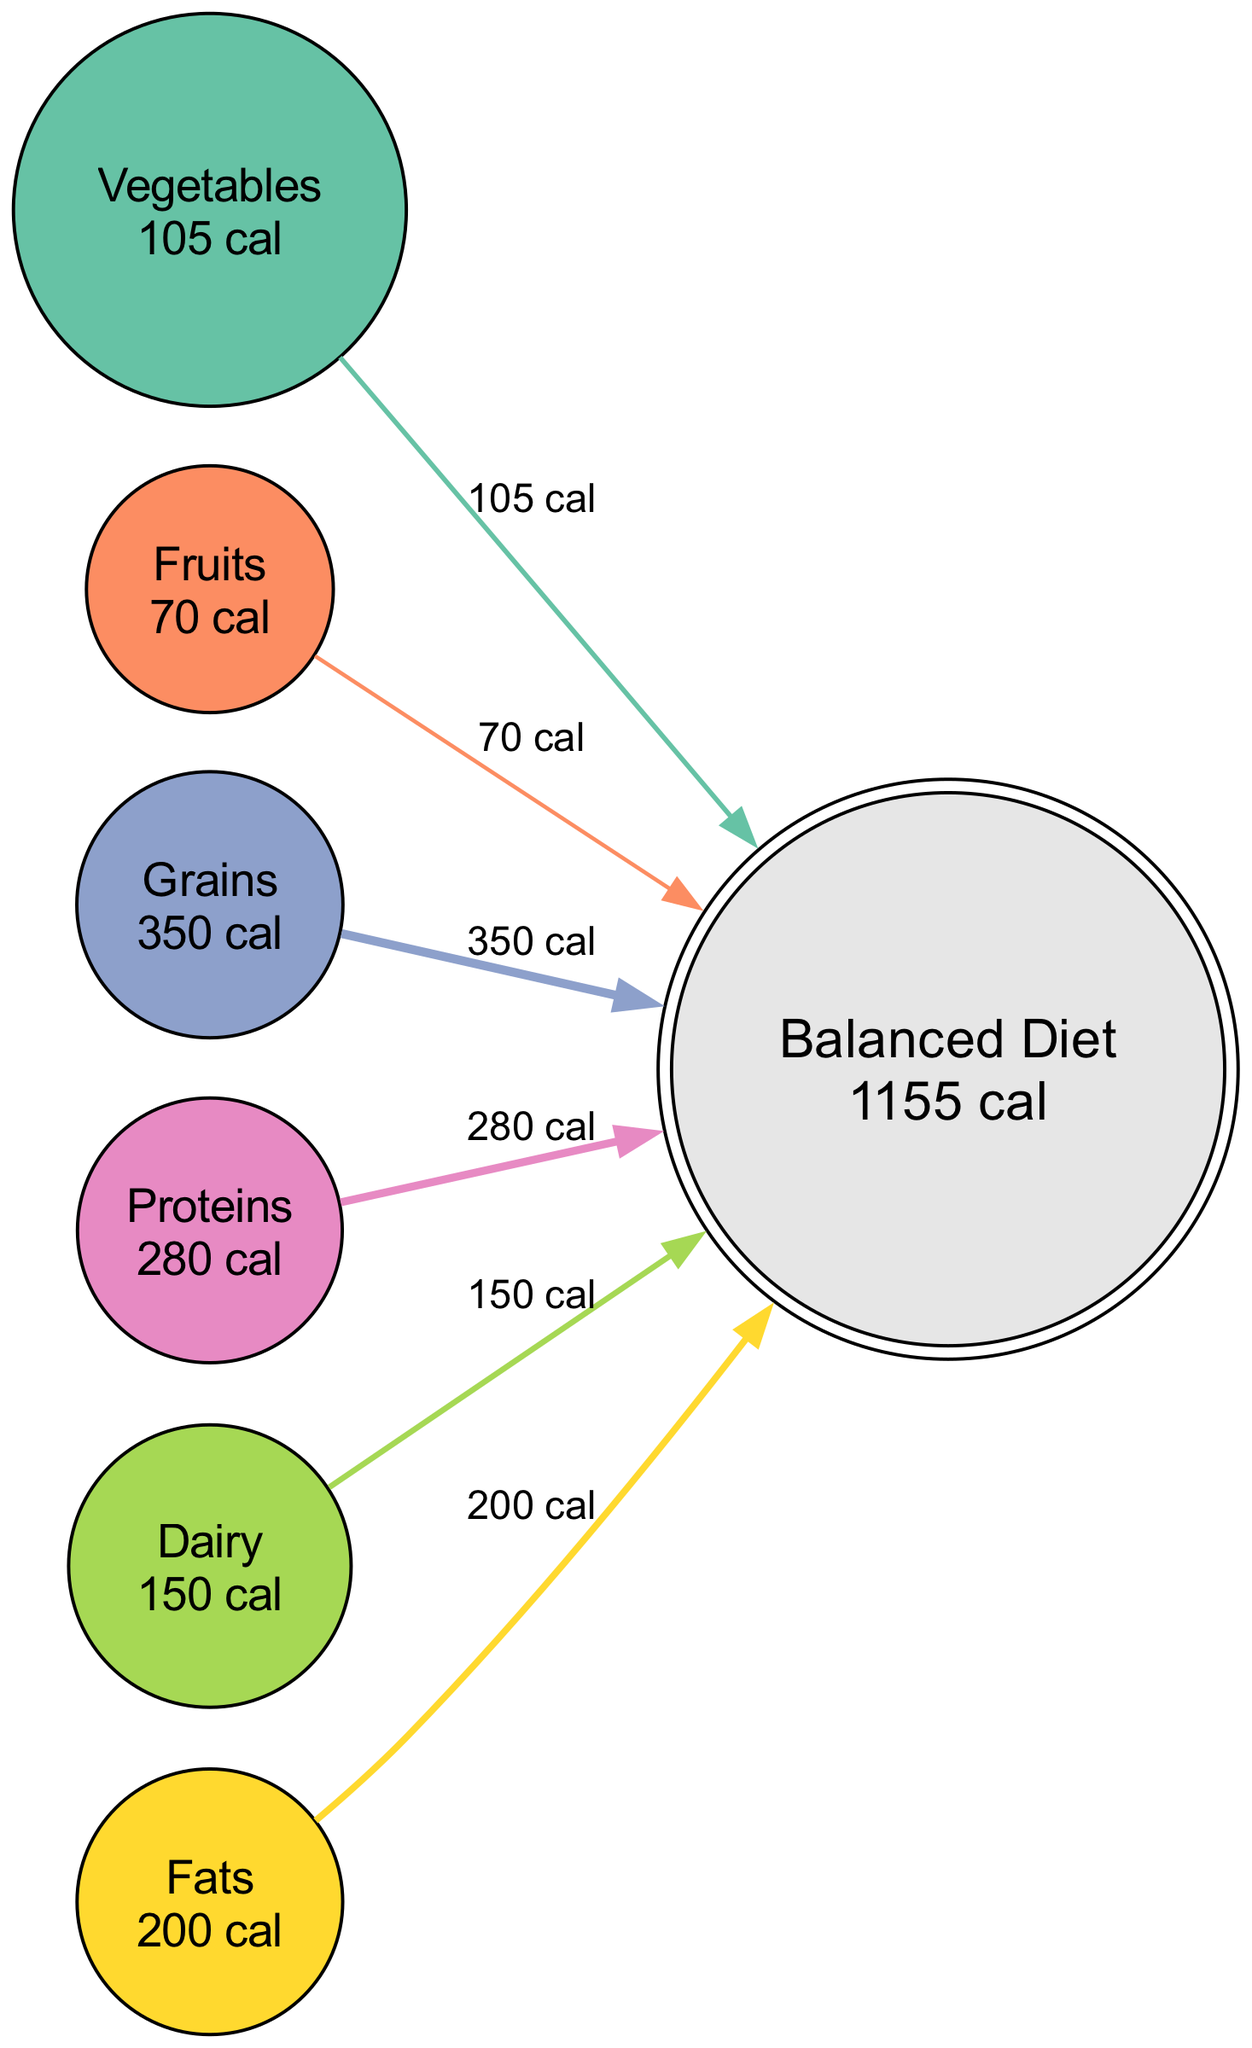What is the total caloric intake from Grains in the balanced diet? The diagram shows that the Grains node is linked to the Balanced Diet with a value of 350 calories. This value is directly indicated next to the Grains node.
Answer: 350 calories How many food groups contribute to the balanced diet? The diagram includes six food groups: Vegetables, Fruits, Grains, Proteins, Dairy, and Fats, all of which link to the Balanced Diet. This counts as six distinct groups.
Answer: 6 food groups Which food group has the highest caloric value? By examining the caloric values assigned to each food group, Grains has the highest value of 350 calories, as indicated in the diagram.
Answer: Grains What is the total caloric intake represented in the Balanced Diet node? The Balanced Diet node summarizes the total caloric intake from all food groups. By adding the values of all nodes (105 + 70 + 350 + 280 + 150 + 200), the total comes to 1155 calories, which is also explicitly labeled in the Balanced Diet node.
Answer: 1155 calories Which food group provides the least amount of calories? The diagram shows that the Fruits node has 70 calories, which is the smallest value presented among all food groups.
Answer: Fruits What percentage of the total caloric intake comes from Proteins? To find the percentage from Proteins, divide its caloric value (280) by the total (1155) and multiply by 100. This gives approximately 24.2 percent.
Answer: 24.2 percent Which two food groups together provide a caloric intake of 455 calories? Adding the values of Grains (350) and Dairy (150) gives a total of 500 calories. However, considering Proteins (280) and Dairy (150) yields 430 total while Grains (350) and Vegetables (105) yield certain combinations that exceed this total. Observing nodes shows no two groups equate to exactly 455; thus, they only need to exceed as needed.
Answer: No specific pair equals 455 calories What links all the food groups to the Balanced Diet? Each food group has a dedicated link that shows the flow of calories from the respective nodes to the Balanced Diet node. This structural connection is indicated by the edges drawn between each node to the central Balanced Diet node.
Answer: Directed edges What color represents the Fats food group in the diagram? The Fats node is colored in a shade indicated by the color mapping used in the diagram, specifically using the 5th color in the predefined palette scheme, which can be visually identified in the rendered diagram.
Answer: Specific shade from the palette (not individually listed but identifiable in the diagram) 